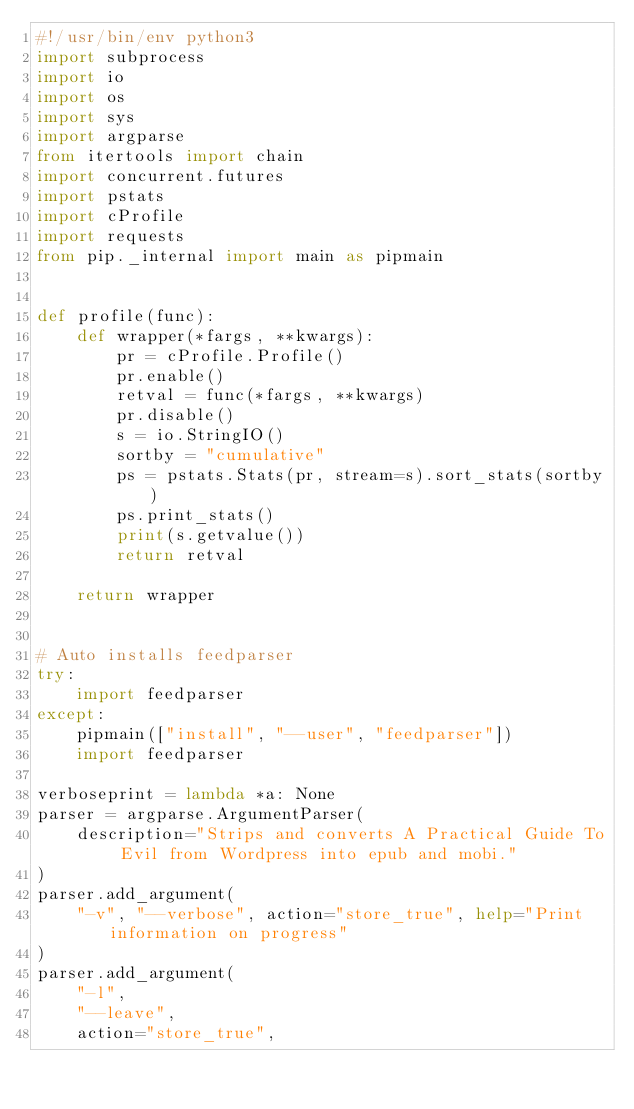<code> <loc_0><loc_0><loc_500><loc_500><_Python_>#!/usr/bin/env python3
import subprocess
import io
import os
import sys
import argparse
from itertools import chain
import concurrent.futures
import pstats
import cProfile
import requests
from pip._internal import main as pipmain


def profile(func):
    def wrapper(*fargs, **kwargs):
        pr = cProfile.Profile()
        pr.enable()
        retval = func(*fargs, **kwargs)
        pr.disable()
        s = io.StringIO()
        sortby = "cumulative"
        ps = pstats.Stats(pr, stream=s).sort_stats(sortby)
        ps.print_stats()
        print(s.getvalue())
        return retval

    return wrapper


# Auto installs feedparser
try:
    import feedparser
except:
    pipmain(["install", "--user", "feedparser"])
    import feedparser

verboseprint = lambda *a: None
parser = argparse.ArgumentParser(
    description="Strips and converts A Practical Guide To Evil from Wordpress into epub and mobi."
)
parser.add_argument(
    "-v", "--verbose", action="store_true", help="Print information on progress"
)
parser.add_argument(
    "-l",
    "--leave",
    action="store_true",</code> 